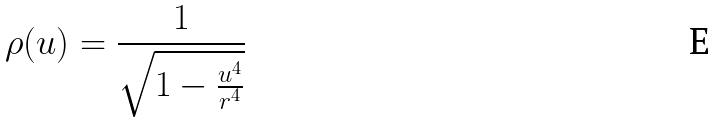<formula> <loc_0><loc_0><loc_500><loc_500>\rho ( u ) = \frac { 1 } { \sqrt { 1 - \frac { u ^ { 4 } } { r ^ { 4 } } } }</formula> 